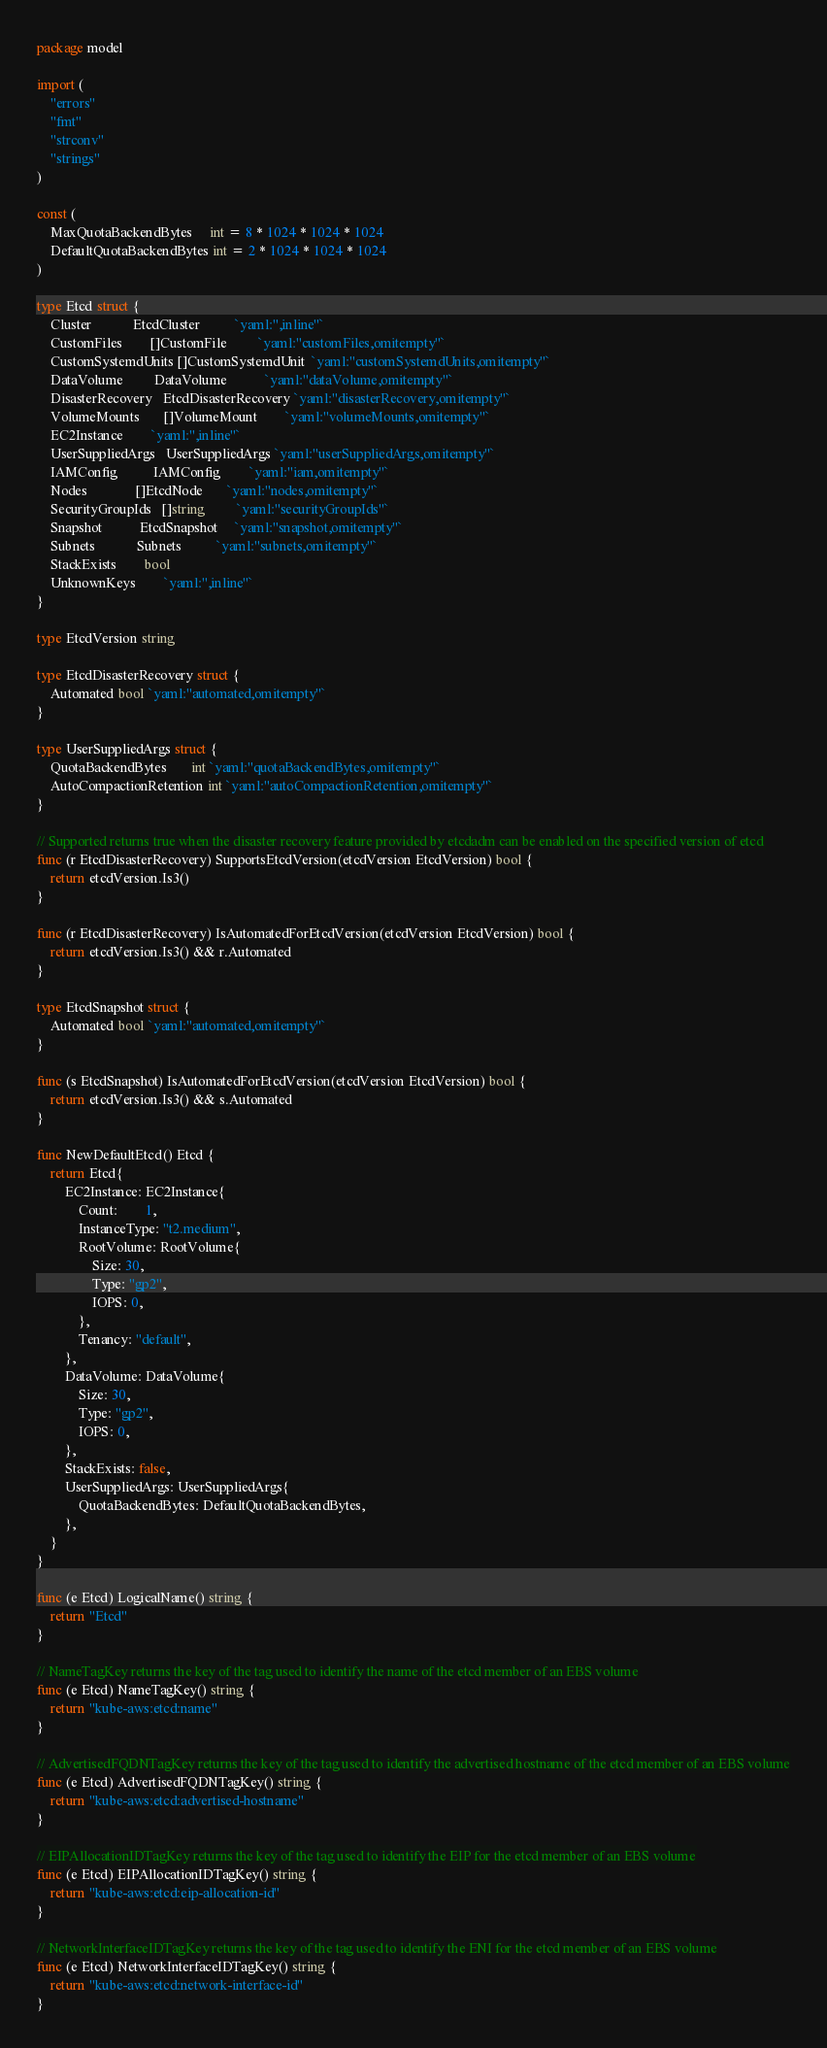Convert code to text. <code><loc_0><loc_0><loc_500><loc_500><_Go_>package model

import (
	"errors"
	"fmt"
	"strconv"
	"strings"
)

const (
	MaxQuotaBackendBytes     int = 8 * 1024 * 1024 * 1024
	DefaultQuotaBackendBytes int = 2 * 1024 * 1024 * 1024
)

type Etcd struct {
	Cluster            EtcdCluster          `yaml:",inline"`
	CustomFiles        []CustomFile         `yaml:"customFiles,omitempty"`
	CustomSystemdUnits []CustomSystemdUnit  `yaml:"customSystemdUnits,omitempty"`
	DataVolume         DataVolume           `yaml:"dataVolume,omitempty"`
	DisasterRecovery   EtcdDisasterRecovery `yaml:"disasterRecovery,omitempty"`
	VolumeMounts       []VolumeMount        `yaml:"volumeMounts,omitempty"`
	EC2Instance        `yaml:",inline"`
	UserSuppliedArgs   UserSuppliedArgs `yaml:"userSuppliedArgs,omitempty"`
	IAMConfig          IAMConfig        `yaml:"iam,omitempty"`
	Nodes              []EtcdNode       `yaml:"nodes,omitempty"`
	SecurityGroupIds   []string         `yaml:"securityGroupIds"`
	Snapshot           EtcdSnapshot     `yaml:"snapshot,omitempty"`
	Subnets            Subnets          `yaml:"subnets,omitempty"`
	StackExists        bool
	UnknownKeys        `yaml:",inline"`
}

type EtcdVersion string

type EtcdDisasterRecovery struct {
	Automated bool `yaml:"automated,omitempty"`
}

type UserSuppliedArgs struct {
	QuotaBackendBytes       int `yaml:"quotaBackendBytes,omitempty"`
	AutoCompactionRetention int `yaml:"autoCompactionRetention,omitempty"`
}

// Supported returns true when the disaster recovery feature provided by etcdadm can be enabled on the specified version of etcd
func (r EtcdDisasterRecovery) SupportsEtcdVersion(etcdVersion EtcdVersion) bool {
	return etcdVersion.Is3()
}

func (r EtcdDisasterRecovery) IsAutomatedForEtcdVersion(etcdVersion EtcdVersion) bool {
	return etcdVersion.Is3() && r.Automated
}

type EtcdSnapshot struct {
	Automated bool `yaml:"automated,omitempty"`
}

func (s EtcdSnapshot) IsAutomatedForEtcdVersion(etcdVersion EtcdVersion) bool {
	return etcdVersion.Is3() && s.Automated
}

func NewDefaultEtcd() Etcd {
	return Etcd{
		EC2Instance: EC2Instance{
			Count:        1,
			InstanceType: "t2.medium",
			RootVolume: RootVolume{
				Size: 30,
				Type: "gp2",
				IOPS: 0,
			},
			Tenancy: "default",
		},
		DataVolume: DataVolume{
			Size: 30,
			Type: "gp2",
			IOPS: 0,
		},
		StackExists: false,
		UserSuppliedArgs: UserSuppliedArgs{
			QuotaBackendBytes: DefaultQuotaBackendBytes,
		},
	}
}

func (e Etcd) LogicalName() string {
	return "Etcd"
}

// NameTagKey returns the key of the tag used to identify the name of the etcd member of an EBS volume
func (e Etcd) NameTagKey() string {
	return "kube-aws:etcd:name"
}

// AdvertisedFQDNTagKey returns the key of the tag used to identify the advertised hostname of the etcd member of an EBS volume
func (e Etcd) AdvertisedFQDNTagKey() string {
	return "kube-aws:etcd:advertised-hostname"
}

// EIPAllocationIDTagKey returns the key of the tag used to identify the EIP for the etcd member of an EBS volume
func (e Etcd) EIPAllocationIDTagKey() string {
	return "kube-aws:etcd:eip-allocation-id"
}

// NetworkInterfaceIDTagKey returns the key of the tag used to identify the ENI for the etcd member of an EBS volume
func (e Etcd) NetworkInterfaceIDTagKey() string {
	return "kube-aws:etcd:network-interface-id"
}
</code> 